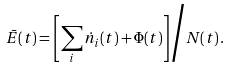<formula> <loc_0><loc_0><loc_500><loc_500>\bar { E } ( t ) = \left [ \sum _ { i } \dot { n } _ { i } ( t ) + \Phi ( t ) \right ] \Big / N ( t ) \, .</formula> 